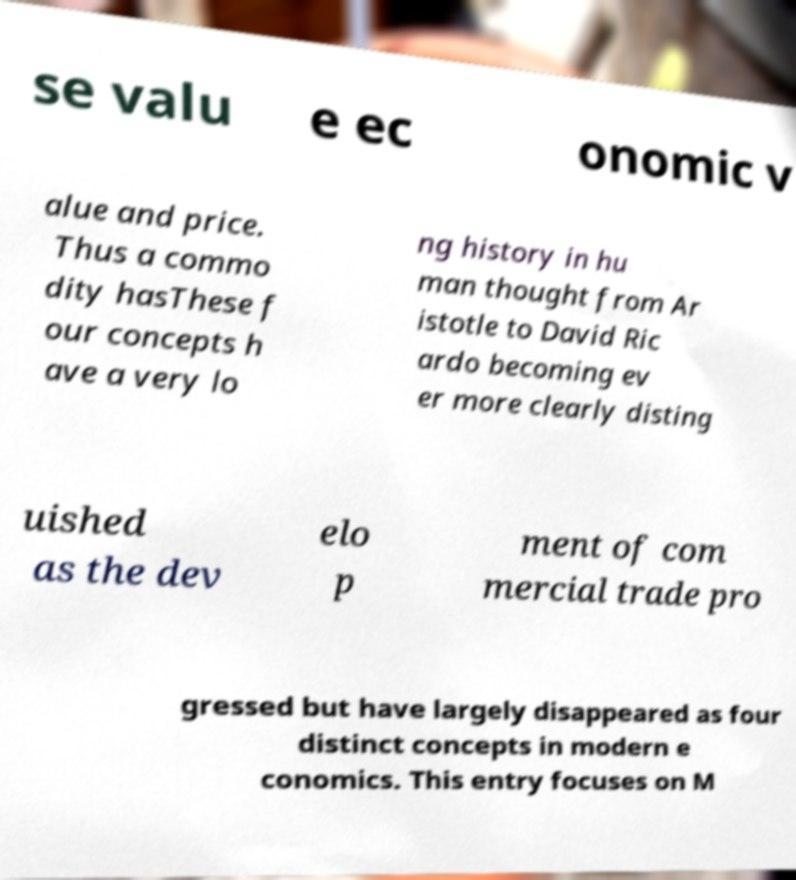For documentation purposes, I need the text within this image transcribed. Could you provide that? se valu e ec onomic v alue and price. Thus a commo dity hasThese f our concepts h ave a very lo ng history in hu man thought from Ar istotle to David Ric ardo becoming ev er more clearly disting uished as the dev elo p ment of com mercial trade pro gressed but have largely disappeared as four distinct concepts in modern e conomics. This entry focuses on M 